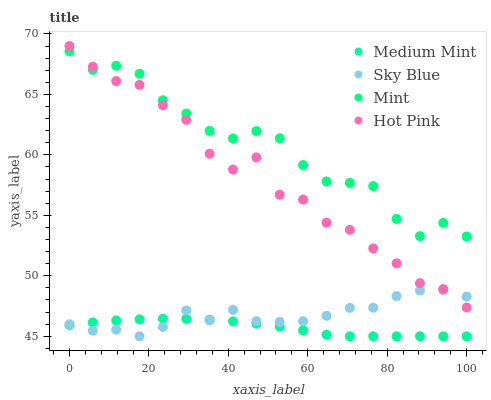Does Medium Mint have the minimum area under the curve?
Answer yes or no. Yes. Does Mint have the maximum area under the curve?
Answer yes or no. Yes. Does Sky Blue have the minimum area under the curve?
Answer yes or no. No. Does Sky Blue have the maximum area under the curve?
Answer yes or no. No. Is Medium Mint the smoothest?
Answer yes or no. Yes. Is Hot Pink the roughest?
Answer yes or no. Yes. Is Sky Blue the smoothest?
Answer yes or no. No. Is Sky Blue the roughest?
Answer yes or no. No. Does Medium Mint have the lowest value?
Answer yes or no. Yes. Does Hot Pink have the lowest value?
Answer yes or no. No. Does Hot Pink have the highest value?
Answer yes or no. Yes. Does Sky Blue have the highest value?
Answer yes or no. No. Is Sky Blue less than Mint?
Answer yes or no. Yes. Is Hot Pink greater than Medium Mint?
Answer yes or no. Yes. Does Sky Blue intersect Hot Pink?
Answer yes or no. Yes. Is Sky Blue less than Hot Pink?
Answer yes or no. No. Is Sky Blue greater than Hot Pink?
Answer yes or no. No. Does Sky Blue intersect Mint?
Answer yes or no. No. 